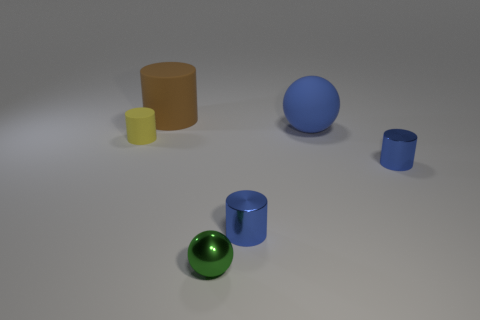Can you describe the sizes and colors of the objects in the image? Certainly! The image features a collection of geometric shapes of varied sizes and colors. Close to the forefront is a green sphere, somewhat reflective. Behind it to the left is a brown cylinder, medium in height. There's a tall blue cylinder, and a small one of the same color to its right. Another object present is a large blue sphere, placed near the center. And finally, there's a small yellow cylinder sitting in the back, to the left side. 